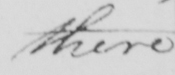Please provide the text content of this handwritten line. there 